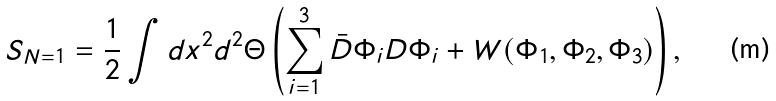<formula> <loc_0><loc_0><loc_500><loc_500>S _ { N = 1 } = \frac { 1 } { 2 } \int d x ^ { 2 } d ^ { 2 } \Theta \left ( \sum _ { i = 1 } ^ { 3 } \bar { D } \Phi _ { i } D \Phi _ { i } + W ( \Phi _ { 1 } , \Phi _ { 2 } , \Phi _ { 3 } ) \right ) ,</formula> 